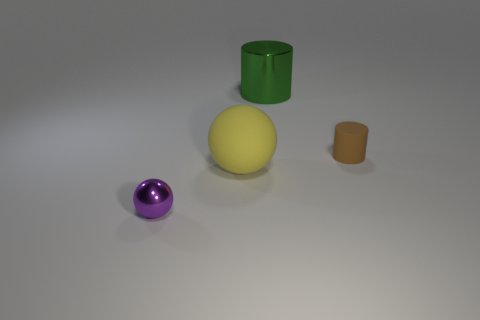What materials do these objects appear to be made of? The objects in the image look like they could be made of a smooth, matte plastic. This is suggested by the even light reflections and the absence of any textural imperfections usually found in natural materials. 